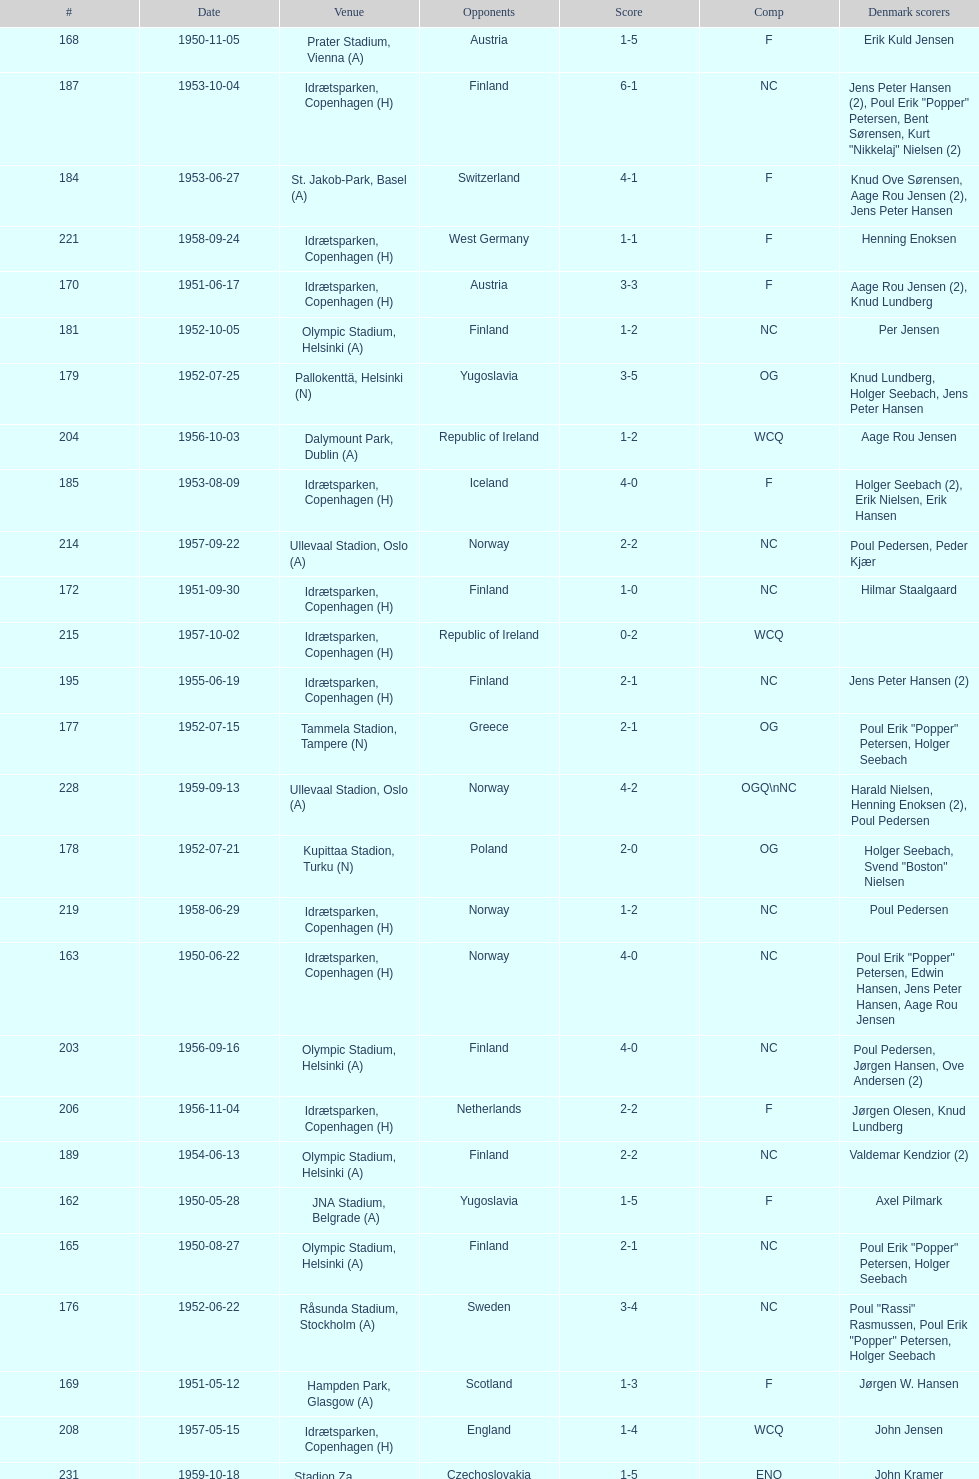Who did they play in the game listed directly above july 25, 1952? Poland. 